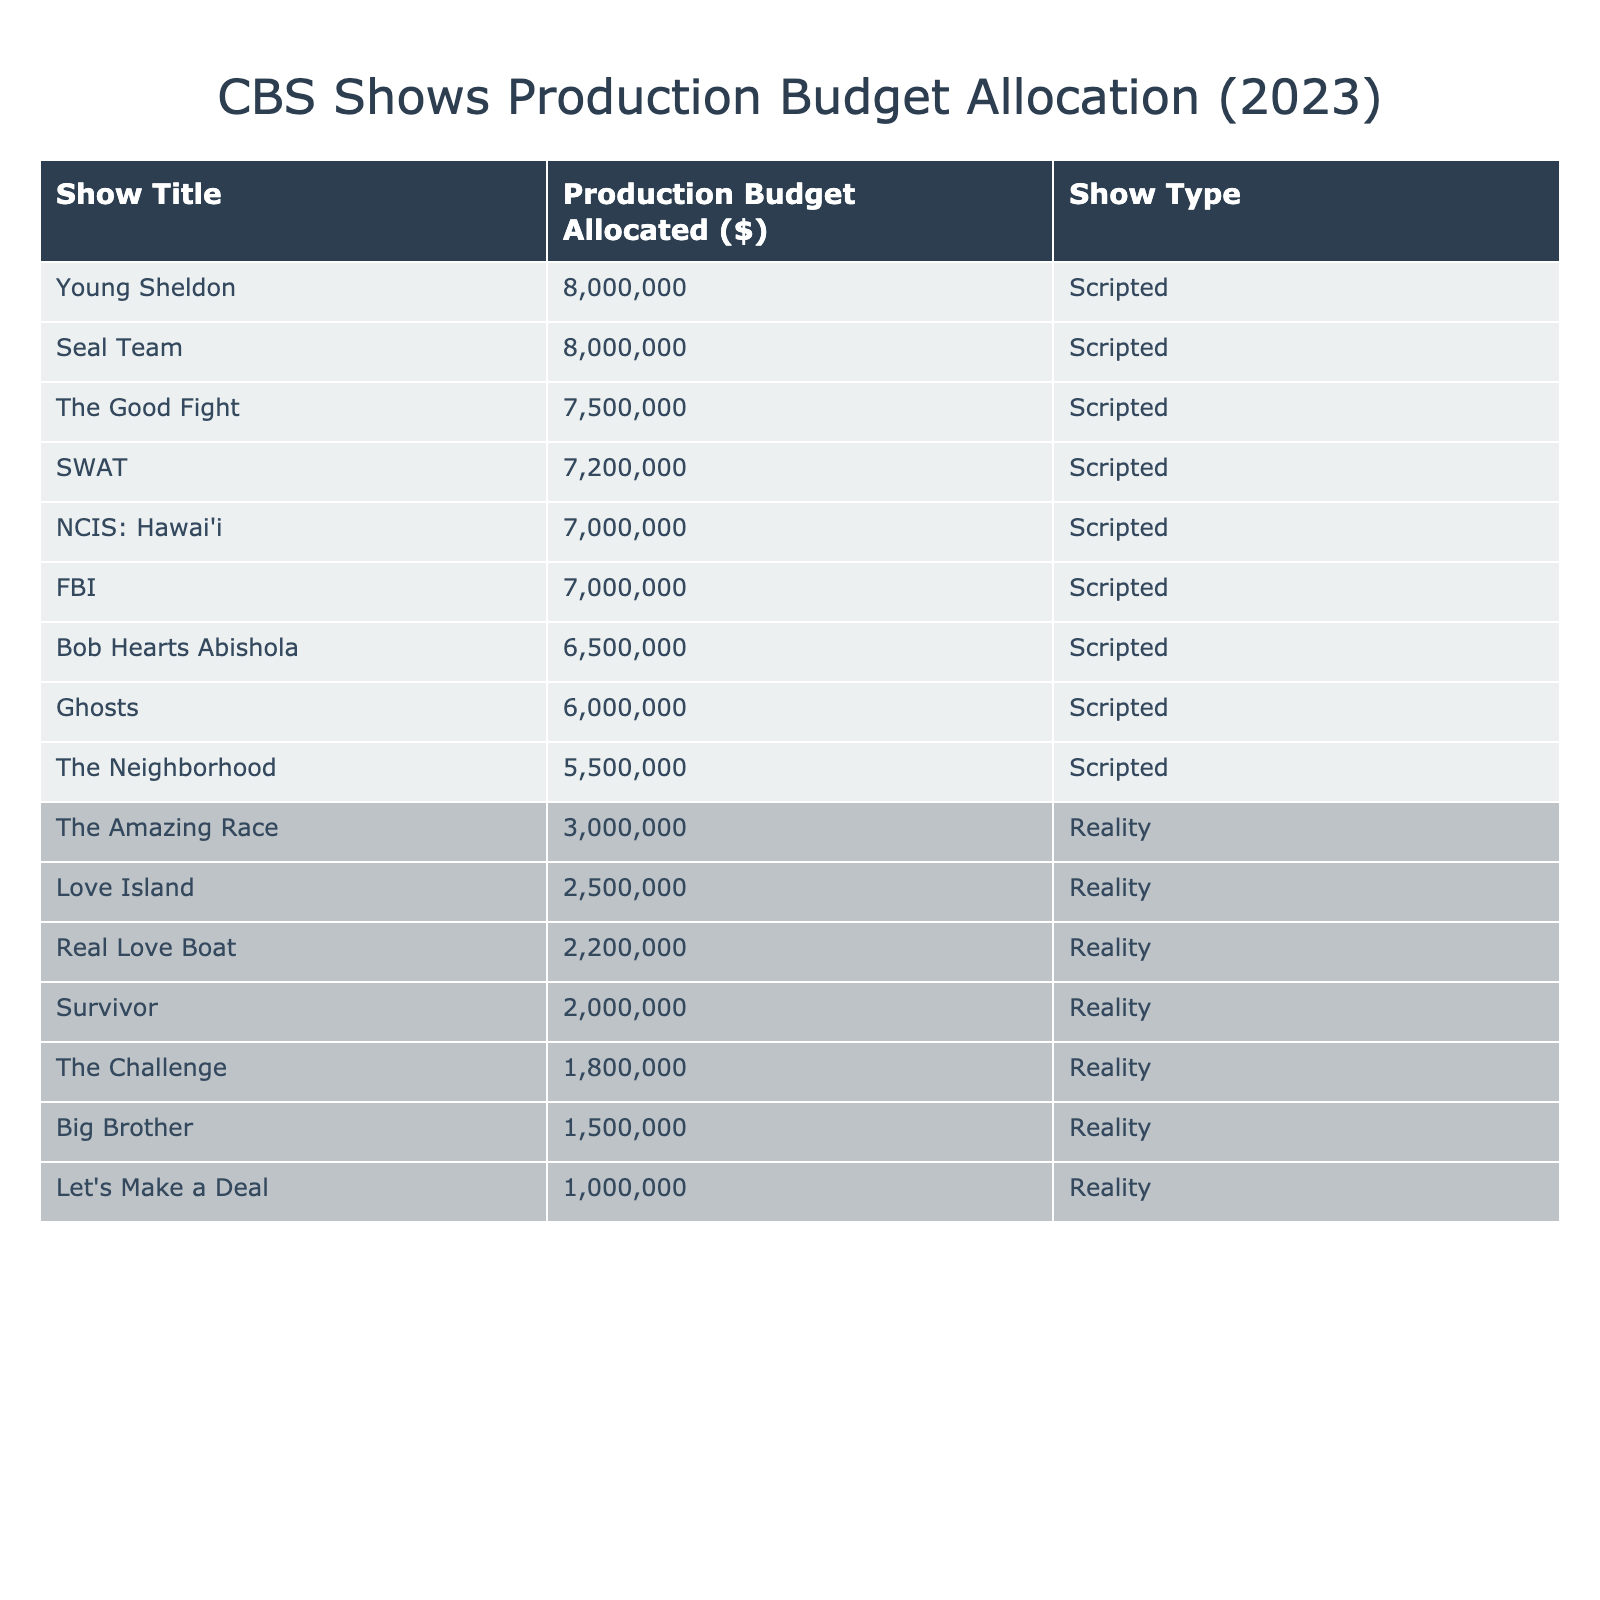What is the production budget allocated for "Young Sheldon"? From the table, "Young Sheldon" is listed with a production budget of 8,000,000 dollars.
Answer: 8,000,000 How many reality shows are listed in the table? Counting the entries under 'Show Type' as "Reality," there are a total of 5 reality shows in the table: "Survivor," "The Amazing Race," "Big Brother," "Love Island," and "The Challenge."
Answer: 5 What is the average production budget for CBS scripted shows? The scripted shows and their budgets are: 7500000, 6500000, 7000000, 8000000, 7000000, 5500000, 7200000, and 8000000. The sum is 4,900,000 and there are 8 shows, so the average is 4,900,000 / 8 = 6887500.
Answer: 6,887,500 Is the production budget for "Survivor" higher than that for "The Neighborhood"? The production budget for "Survivor" is 2,000,000 dollars while "The Neighborhood" has a budget of 5,500,000 dollars. Therefore, 2,000,000 is less than 5,500,000, making the statement false.
Answer: No How much more is the total production budget for scripted shows compared to reality shows? The total budget for scripted shows is 8,000,000 + 7,500,000 + 6,500,000 + 7,000,000 + 7,200,000 + 5,500,000 + 8,000,000 = 51,900,000. The total for reality shows is 2,000,000 + 3,000,000 + 1,500,000 + 2,500,000 + 1,800,000 + 2,200,000 + 1,000,000 = 12,000,000. The difference is 51,900,000 - 12,000,000 = 39,900,000.
Answer: 39,900,000 Which show has the lowest production budget overall? Looking at the production budgets of all shows in the table, "Let's Make a Deal" has the lowest budget listed at 1,000,000 dollars.
Answer: Let's Make a Deal Which scripted show has a production budget closest to 7 million dollars? The scripted shows with budgets near 7 million dollars are "NCIS: Hawai'i" at 7,000,000 dollars and "FBI" also at 7,000,000 dollars. They are equally closest to that amount.
Answer: NCIS: Hawai'i and FBI Is the production budget allocation for scripted shows generally higher than that of reality shows? Comparing the total budgets, scripted shows totaled 51,900,000 dollars while reality shows totaled 12,000,000 dollars, confirming that the budget for scripted shows is indeed higher.
Answer: Yes How much does "Big Brother's" budget compare to the average budget of reality shows? First, the average budget for reality shows can be calculated from their totals of 2,000,000, 3,000,000, 1,500,000, 2,500,000, 1,800,000, 2,200,000, and 1,000,000, totaling 12,000,000. The number of reality shows is 7, giving an average of 12,000,000 / 7 = 1,714,285.714. "Big Brother" has a budget of 1,500,000, which is lower than the average.
Answer: Lower than average 